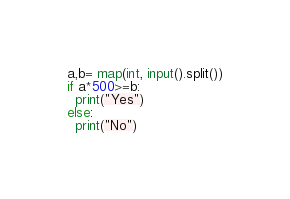Convert code to text. <code><loc_0><loc_0><loc_500><loc_500><_Python_>a,b= map(int, input().split())
if a*500>=b:
  print("Yes")
else:
  print("No")</code> 